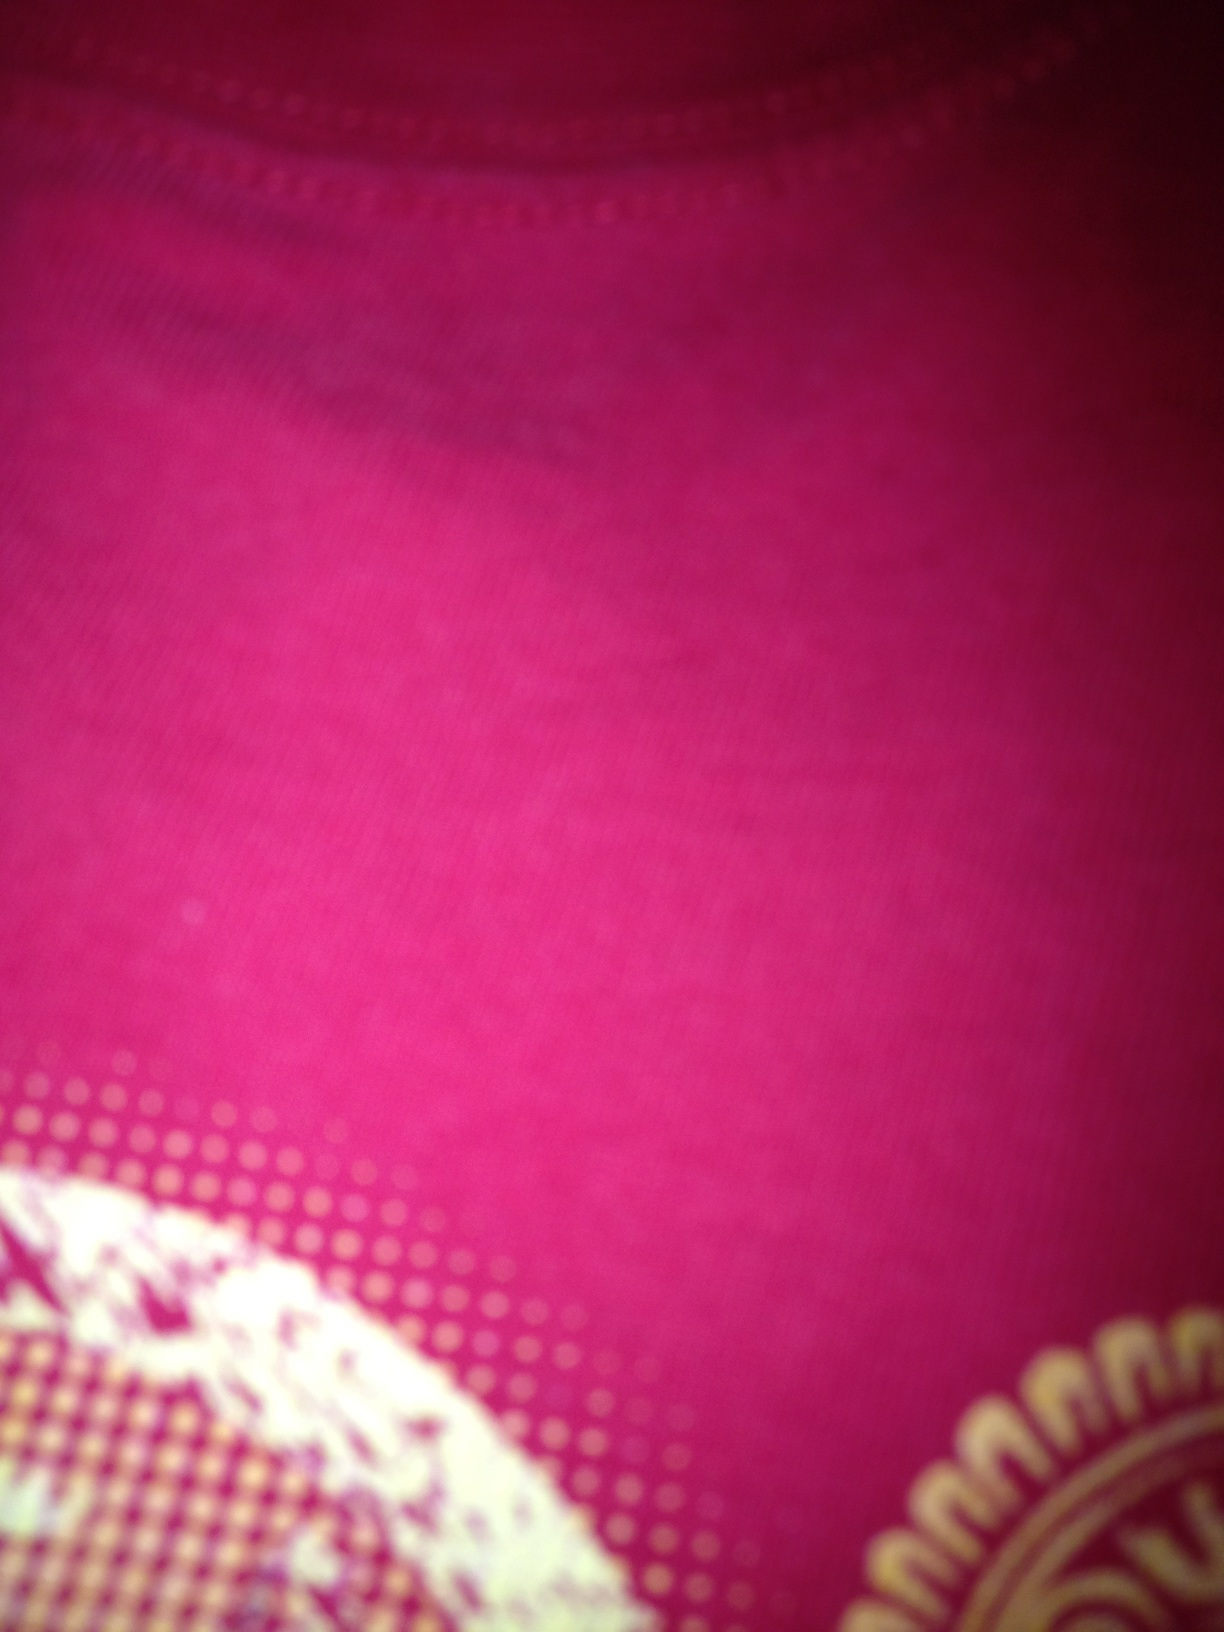Is there any special pattern or design visible? Yes, in the corner of the image, you can see part of a decorative pattern that seems to incorporate dotted elements, and what might be a floral or paisley design, suggesting this could be a piece of traditional or ethnic attire. 